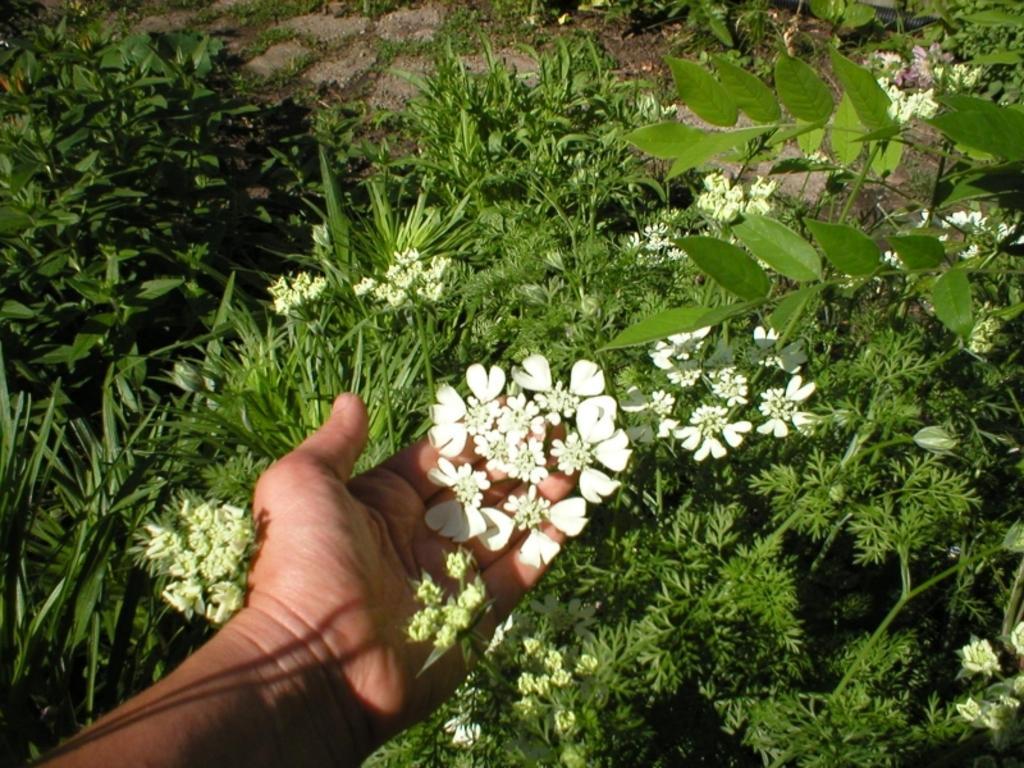How would you summarize this image in a sentence or two? In this image we can see a person holding flowers. We can see the human hand. We can see the grass and plants. 